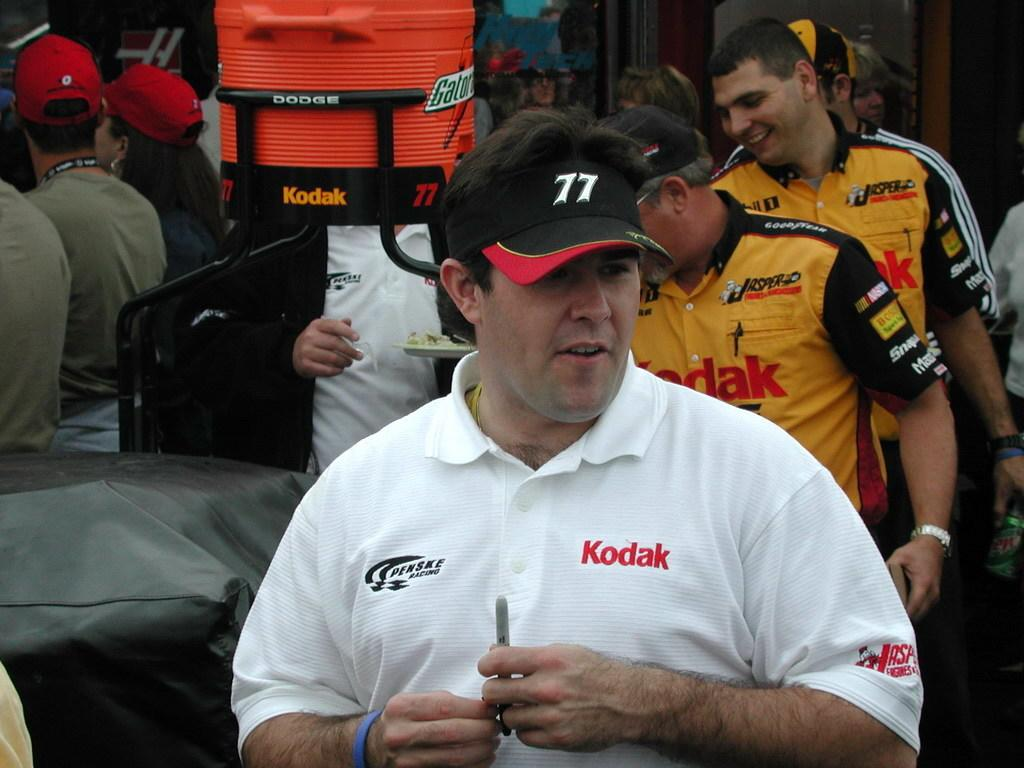<image>
Create a compact narrative representing the image presented. A man in a black visor displaying the number 77. 